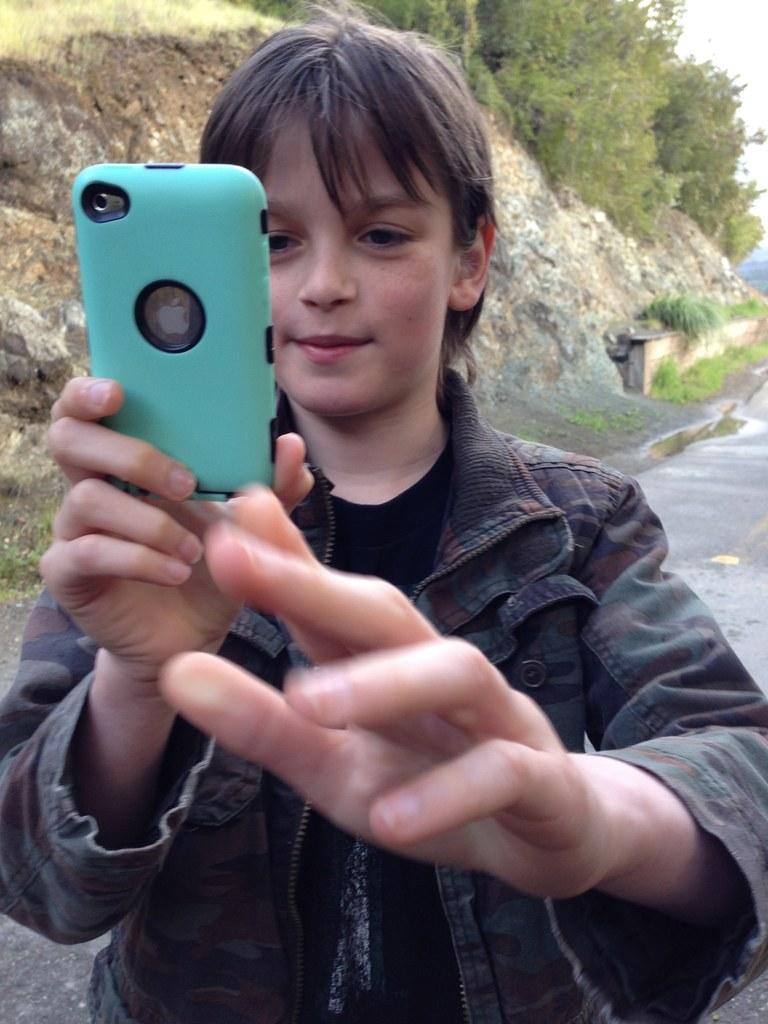Who is the main subject in the image? There is a boy in the image. What is the boy holding in his hand? The boy is holding a phone in his hand. What can be seen in the background of the image? There are trees and the sky visible in the background of the image. What type of pollution is visible in the image? There is no visible pollution in the image; it features a boy holding a phone with trees and the sky in the background. 